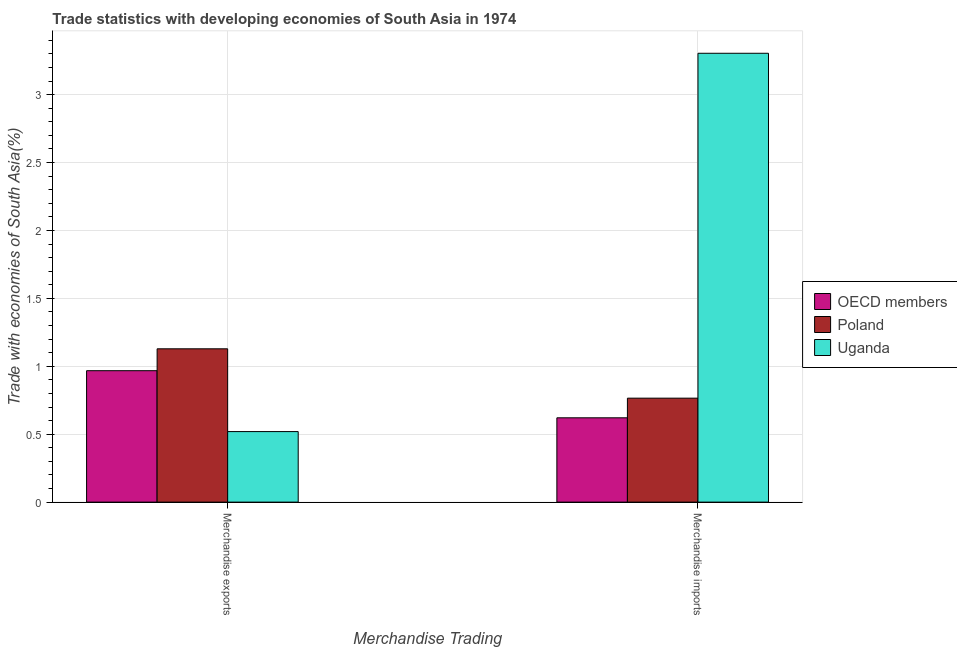Are the number of bars on each tick of the X-axis equal?
Your answer should be very brief. Yes. How many bars are there on the 1st tick from the left?
Make the answer very short. 3. What is the label of the 1st group of bars from the left?
Ensure brevity in your answer.  Merchandise exports. What is the merchandise exports in OECD members?
Keep it short and to the point. 0.97. Across all countries, what is the maximum merchandise exports?
Your answer should be compact. 1.13. Across all countries, what is the minimum merchandise exports?
Keep it short and to the point. 0.52. In which country was the merchandise imports maximum?
Ensure brevity in your answer.  Uganda. In which country was the merchandise exports minimum?
Offer a very short reply. Uganda. What is the total merchandise exports in the graph?
Your response must be concise. 2.62. What is the difference between the merchandise exports in Uganda and that in OECD members?
Offer a very short reply. -0.45. What is the difference between the merchandise imports in Uganda and the merchandise exports in Poland?
Offer a very short reply. 2.18. What is the average merchandise imports per country?
Your answer should be compact. 1.56. What is the difference between the merchandise imports and merchandise exports in OECD members?
Your answer should be very brief. -0.35. What is the ratio of the merchandise exports in Poland to that in Uganda?
Provide a succinct answer. 2.17. Is the merchandise exports in OECD members less than that in Poland?
Make the answer very short. Yes. In how many countries, is the merchandise exports greater than the average merchandise exports taken over all countries?
Keep it short and to the point. 2. What does the 1st bar from the right in Merchandise imports represents?
Your answer should be very brief. Uganda. How many bars are there?
Ensure brevity in your answer.  6. How many countries are there in the graph?
Give a very brief answer. 3. What is the difference between two consecutive major ticks on the Y-axis?
Keep it short and to the point. 0.5. What is the title of the graph?
Make the answer very short. Trade statistics with developing economies of South Asia in 1974. What is the label or title of the X-axis?
Provide a succinct answer. Merchandise Trading. What is the label or title of the Y-axis?
Give a very brief answer. Trade with economies of South Asia(%). What is the Trade with economies of South Asia(%) of OECD members in Merchandise exports?
Your response must be concise. 0.97. What is the Trade with economies of South Asia(%) of Poland in Merchandise exports?
Keep it short and to the point. 1.13. What is the Trade with economies of South Asia(%) in Uganda in Merchandise exports?
Your answer should be very brief. 0.52. What is the Trade with economies of South Asia(%) of OECD members in Merchandise imports?
Keep it short and to the point. 0.62. What is the Trade with economies of South Asia(%) in Poland in Merchandise imports?
Your answer should be very brief. 0.77. What is the Trade with economies of South Asia(%) of Uganda in Merchandise imports?
Keep it short and to the point. 3.3. Across all Merchandise Trading, what is the maximum Trade with economies of South Asia(%) in OECD members?
Offer a very short reply. 0.97. Across all Merchandise Trading, what is the maximum Trade with economies of South Asia(%) in Poland?
Offer a very short reply. 1.13. Across all Merchandise Trading, what is the maximum Trade with economies of South Asia(%) in Uganda?
Your response must be concise. 3.3. Across all Merchandise Trading, what is the minimum Trade with economies of South Asia(%) in OECD members?
Ensure brevity in your answer.  0.62. Across all Merchandise Trading, what is the minimum Trade with economies of South Asia(%) of Poland?
Offer a terse response. 0.77. Across all Merchandise Trading, what is the minimum Trade with economies of South Asia(%) in Uganda?
Your response must be concise. 0.52. What is the total Trade with economies of South Asia(%) of OECD members in the graph?
Provide a succinct answer. 1.59. What is the total Trade with economies of South Asia(%) of Poland in the graph?
Offer a terse response. 1.89. What is the total Trade with economies of South Asia(%) of Uganda in the graph?
Provide a succinct answer. 3.82. What is the difference between the Trade with economies of South Asia(%) in OECD members in Merchandise exports and that in Merchandise imports?
Your response must be concise. 0.35. What is the difference between the Trade with economies of South Asia(%) in Poland in Merchandise exports and that in Merchandise imports?
Your response must be concise. 0.36. What is the difference between the Trade with economies of South Asia(%) in Uganda in Merchandise exports and that in Merchandise imports?
Your response must be concise. -2.79. What is the difference between the Trade with economies of South Asia(%) in OECD members in Merchandise exports and the Trade with economies of South Asia(%) in Poland in Merchandise imports?
Your response must be concise. 0.2. What is the difference between the Trade with economies of South Asia(%) of OECD members in Merchandise exports and the Trade with economies of South Asia(%) of Uganda in Merchandise imports?
Give a very brief answer. -2.34. What is the difference between the Trade with economies of South Asia(%) of Poland in Merchandise exports and the Trade with economies of South Asia(%) of Uganda in Merchandise imports?
Your answer should be compact. -2.18. What is the average Trade with economies of South Asia(%) in OECD members per Merchandise Trading?
Offer a very short reply. 0.79. What is the average Trade with economies of South Asia(%) in Poland per Merchandise Trading?
Offer a terse response. 0.95. What is the average Trade with economies of South Asia(%) in Uganda per Merchandise Trading?
Offer a very short reply. 1.91. What is the difference between the Trade with economies of South Asia(%) in OECD members and Trade with economies of South Asia(%) in Poland in Merchandise exports?
Offer a very short reply. -0.16. What is the difference between the Trade with economies of South Asia(%) in OECD members and Trade with economies of South Asia(%) in Uganda in Merchandise exports?
Make the answer very short. 0.45. What is the difference between the Trade with economies of South Asia(%) in Poland and Trade with economies of South Asia(%) in Uganda in Merchandise exports?
Offer a terse response. 0.61. What is the difference between the Trade with economies of South Asia(%) of OECD members and Trade with economies of South Asia(%) of Poland in Merchandise imports?
Your answer should be compact. -0.14. What is the difference between the Trade with economies of South Asia(%) in OECD members and Trade with economies of South Asia(%) in Uganda in Merchandise imports?
Your response must be concise. -2.68. What is the difference between the Trade with economies of South Asia(%) in Poland and Trade with economies of South Asia(%) in Uganda in Merchandise imports?
Your answer should be very brief. -2.54. What is the ratio of the Trade with economies of South Asia(%) in OECD members in Merchandise exports to that in Merchandise imports?
Offer a very short reply. 1.56. What is the ratio of the Trade with economies of South Asia(%) of Poland in Merchandise exports to that in Merchandise imports?
Offer a very short reply. 1.47. What is the ratio of the Trade with economies of South Asia(%) in Uganda in Merchandise exports to that in Merchandise imports?
Your answer should be compact. 0.16. What is the difference between the highest and the second highest Trade with economies of South Asia(%) of OECD members?
Provide a short and direct response. 0.35. What is the difference between the highest and the second highest Trade with economies of South Asia(%) of Poland?
Your answer should be compact. 0.36. What is the difference between the highest and the second highest Trade with economies of South Asia(%) in Uganda?
Make the answer very short. 2.79. What is the difference between the highest and the lowest Trade with economies of South Asia(%) of OECD members?
Offer a terse response. 0.35. What is the difference between the highest and the lowest Trade with economies of South Asia(%) in Poland?
Keep it short and to the point. 0.36. What is the difference between the highest and the lowest Trade with economies of South Asia(%) of Uganda?
Offer a terse response. 2.79. 